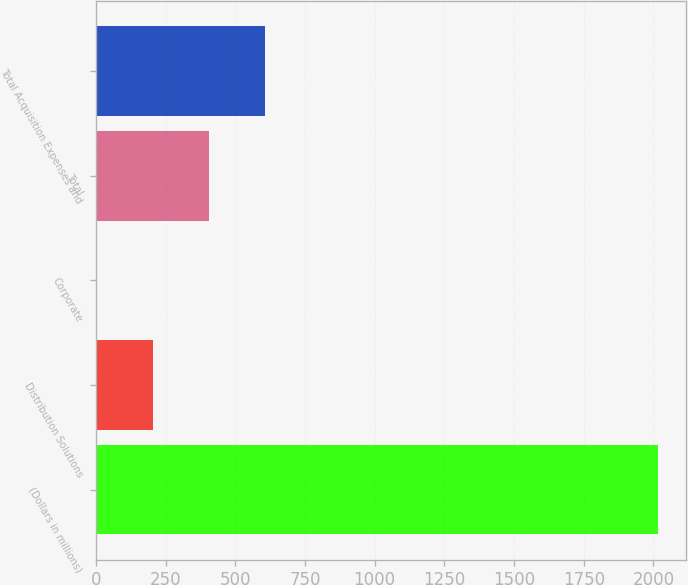<chart> <loc_0><loc_0><loc_500><loc_500><bar_chart><fcel>(Dollars in millions)<fcel>Distribution Solutions<fcel>Corporate<fcel>Total<fcel>Total Acquisition Expenses and<nl><fcel>2016<fcel>203.4<fcel>2<fcel>404.8<fcel>606.2<nl></chart> 